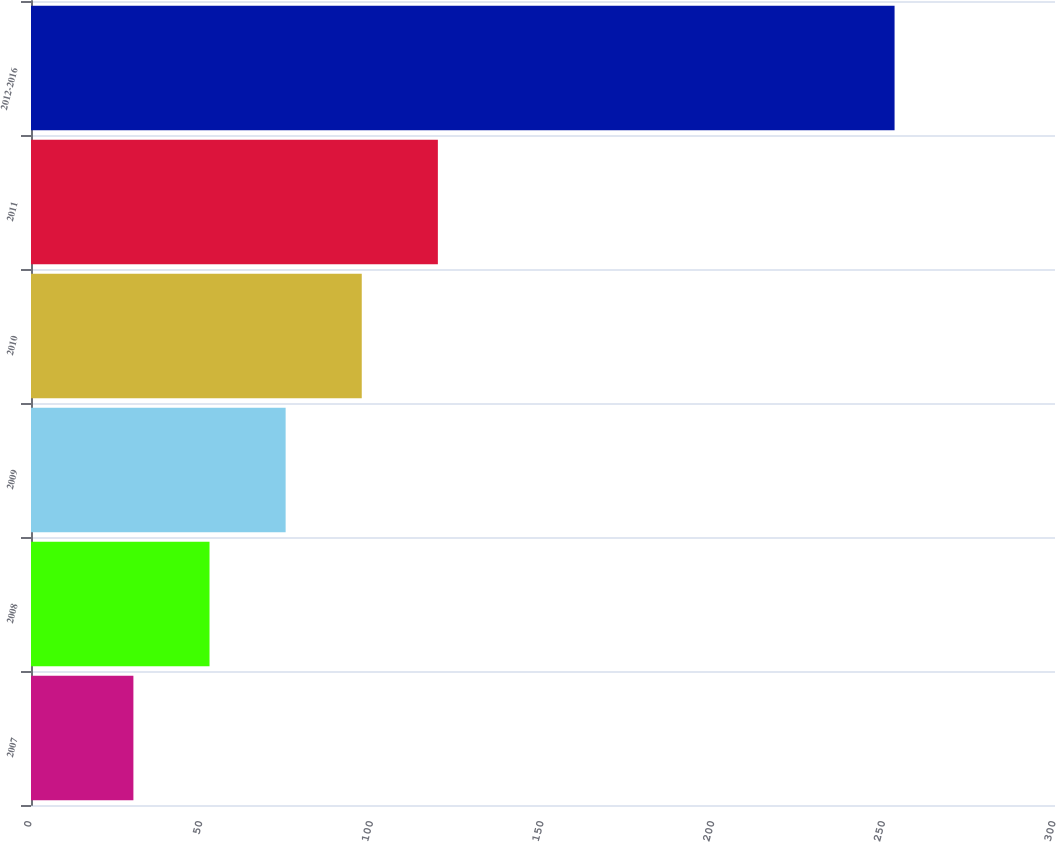Convert chart. <chart><loc_0><loc_0><loc_500><loc_500><bar_chart><fcel>2007<fcel>2008<fcel>2009<fcel>2010<fcel>2011<fcel>2012-2016<nl><fcel>30<fcel>52.3<fcel>74.6<fcel>96.9<fcel>119.2<fcel>253<nl></chart> 